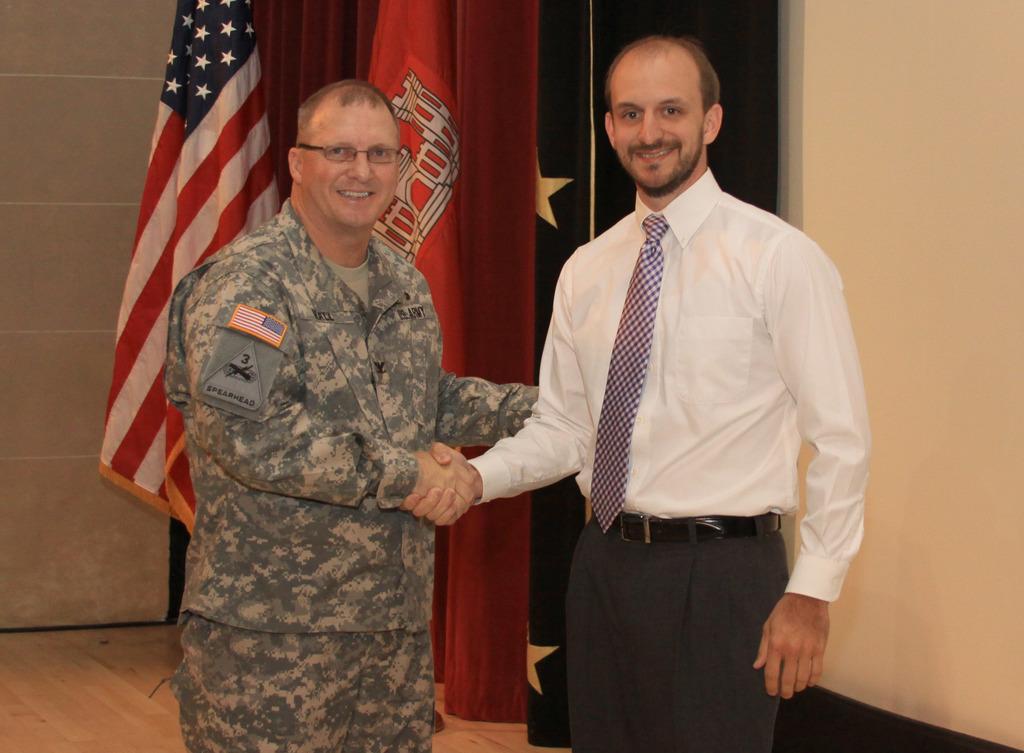In one or two sentences, can you explain what this image depicts? In this picture there is a soldier and another man in the center of the image and there are flags in the background area of the image. 